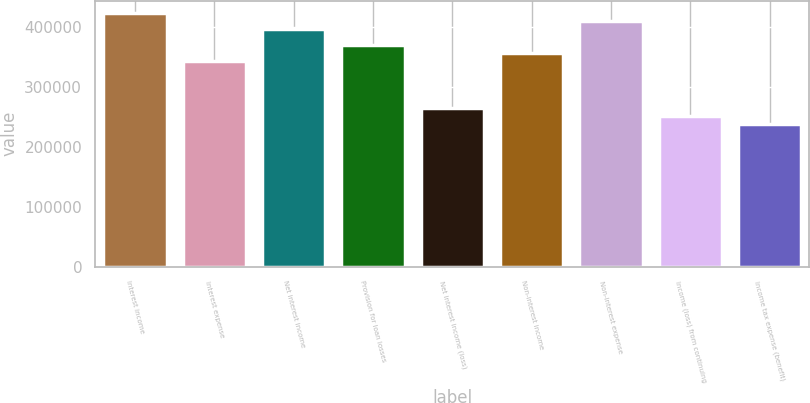Convert chart. <chart><loc_0><loc_0><loc_500><loc_500><bar_chart><fcel>Interest income<fcel>Interest expense<fcel>Net interest income<fcel>Provision for loan losses<fcel>Net interest income (loss)<fcel>Non-interest income<fcel>Non-interest expense<fcel>Income (loss) from continuing<fcel>Income tax expense (benefit)<nl><fcel>423523<fcel>344113<fcel>397053<fcel>370583<fcel>264702<fcel>357348<fcel>410288<fcel>251467<fcel>238232<nl></chart> 